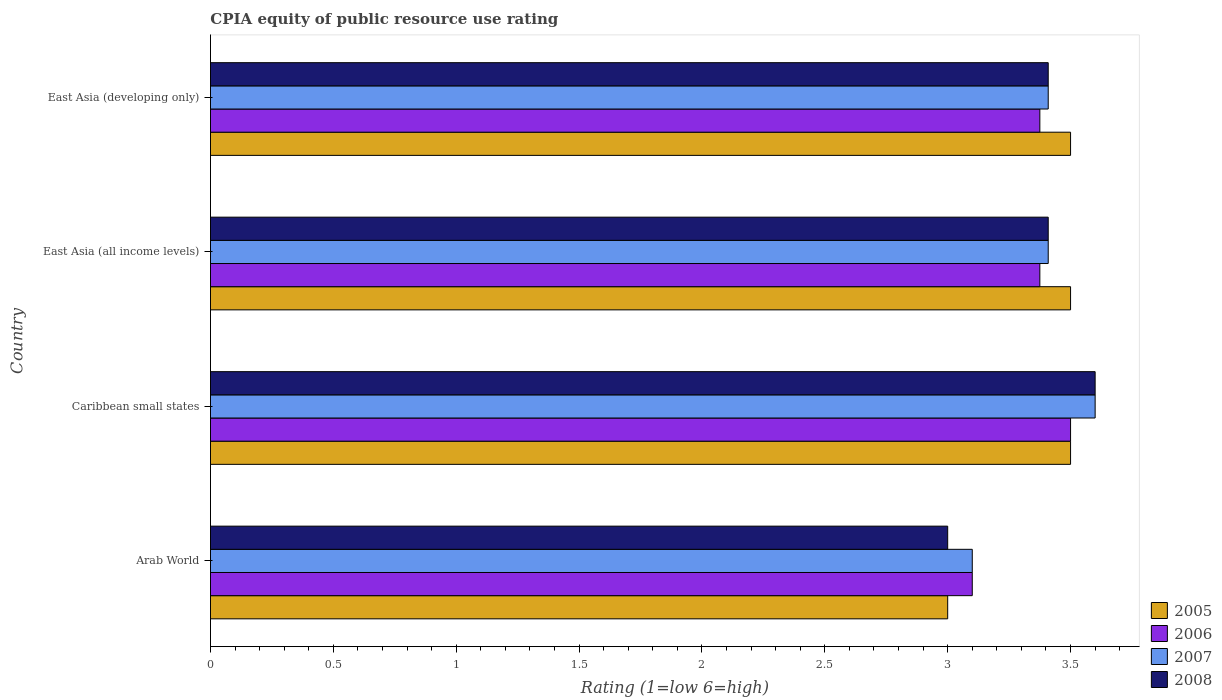Are the number of bars per tick equal to the number of legend labels?
Your answer should be compact. Yes. How many bars are there on the 2nd tick from the top?
Offer a terse response. 4. How many bars are there on the 2nd tick from the bottom?
Offer a terse response. 4. What is the label of the 2nd group of bars from the top?
Your answer should be very brief. East Asia (all income levels). What is the CPIA rating in 2006 in East Asia (all income levels)?
Keep it short and to the point. 3.38. Across all countries, what is the minimum CPIA rating in 2008?
Ensure brevity in your answer.  3. In which country was the CPIA rating in 2007 maximum?
Provide a short and direct response. Caribbean small states. In which country was the CPIA rating in 2006 minimum?
Offer a very short reply. Arab World. What is the total CPIA rating in 2008 in the graph?
Make the answer very short. 13.42. What is the difference between the CPIA rating in 2005 in East Asia (all income levels) and that in East Asia (developing only)?
Your answer should be compact. 0. What is the difference between the CPIA rating in 2007 in Arab World and the CPIA rating in 2008 in East Asia (developing only)?
Keep it short and to the point. -0.31. What is the average CPIA rating in 2006 per country?
Your response must be concise. 3.34. What is the difference between the CPIA rating in 2008 and CPIA rating in 2005 in East Asia (all income levels)?
Your response must be concise. -0.09. Is the CPIA rating in 2005 in Arab World less than that in Caribbean small states?
Give a very brief answer. Yes. Is the difference between the CPIA rating in 2008 in Arab World and East Asia (all income levels) greater than the difference between the CPIA rating in 2005 in Arab World and East Asia (all income levels)?
Your answer should be very brief. Yes. What is the difference between the highest and the second highest CPIA rating in 2008?
Make the answer very short. 0.19. Is the sum of the CPIA rating in 2007 in Arab World and East Asia (all income levels) greater than the maximum CPIA rating in 2005 across all countries?
Your answer should be very brief. Yes. Is it the case that in every country, the sum of the CPIA rating in 2008 and CPIA rating in 2006 is greater than the CPIA rating in 2007?
Your answer should be compact. Yes. How many bars are there?
Provide a short and direct response. 16. Are the values on the major ticks of X-axis written in scientific E-notation?
Your answer should be compact. No. What is the title of the graph?
Provide a succinct answer. CPIA equity of public resource use rating. What is the label or title of the Y-axis?
Your answer should be very brief. Country. What is the Rating (1=low 6=high) in 2005 in Arab World?
Your answer should be very brief. 3. What is the Rating (1=low 6=high) of 2006 in Arab World?
Keep it short and to the point. 3.1. What is the Rating (1=low 6=high) in 2007 in Arab World?
Offer a terse response. 3.1. What is the Rating (1=low 6=high) in 2007 in Caribbean small states?
Your response must be concise. 3.6. What is the Rating (1=low 6=high) in 2008 in Caribbean small states?
Your answer should be compact. 3.6. What is the Rating (1=low 6=high) of 2005 in East Asia (all income levels)?
Keep it short and to the point. 3.5. What is the Rating (1=low 6=high) of 2006 in East Asia (all income levels)?
Your answer should be compact. 3.38. What is the Rating (1=low 6=high) in 2007 in East Asia (all income levels)?
Provide a succinct answer. 3.41. What is the Rating (1=low 6=high) of 2008 in East Asia (all income levels)?
Make the answer very short. 3.41. What is the Rating (1=low 6=high) of 2006 in East Asia (developing only)?
Provide a succinct answer. 3.38. What is the Rating (1=low 6=high) in 2007 in East Asia (developing only)?
Make the answer very short. 3.41. What is the Rating (1=low 6=high) of 2008 in East Asia (developing only)?
Offer a very short reply. 3.41. Across all countries, what is the minimum Rating (1=low 6=high) in 2006?
Give a very brief answer. 3.1. What is the total Rating (1=low 6=high) in 2005 in the graph?
Keep it short and to the point. 13.5. What is the total Rating (1=low 6=high) of 2006 in the graph?
Your answer should be compact. 13.35. What is the total Rating (1=low 6=high) in 2007 in the graph?
Offer a terse response. 13.52. What is the total Rating (1=low 6=high) of 2008 in the graph?
Your answer should be very brief. 13.42. What is the difference between the Rating (1=low 6=high) in 2005 in Arab World and that in Caribbean small states?
Ensure brevity in your answer.  -0.5. What is the difference between the Rating (1=low 6=high) in 2006 in Arab World and that in Caribbean small states?
Your response must be concise. -0.4. What is the difference between the Rating (1=low 6=high) in 2008 in Arab World and that in Caribbean small states?
Make the answer very short. -0.6. What is the difference between the Rating (1=low 6=high) of 2006 in Arab World and that in East Asia (all income levels)?
Offer a terse response. -0.28. What is the difference between the Rating (1=low 6=high) of 2007 in Arab World and that in East Asia (all income levels)?
Offer a terse response. -0.31. What is the difference between the Rating (1=low 6=high) in 2008 in Arab World and that in East Asia (all income levels)?
Provide a short and direct response. -0.41. What is the difference between the Rating (1=low 6=high) of 2006 in Arab World and that in East Asia (developing only)?
Ensure brevity in your answer.  -0.28. What is the difference between the Rating (1=low 6=high) of 2007 in Arab World and that in East Asia (developing only)?
Keep it short and to the point. -0.31. What is the difference between the Rating (1=low 6=high) in 2008 in Arab World and that in East Asia (developing only)?
Offer a very short reply. -0.41. What is the difference between the Rating (1=low 6=high) in 2007 in Caribbean small states and that in East Asia (all income levels)?
Ensure brevity in your answer.  0.19. What is the difference between the Rating (1=low 6=high) in 2008 in Caribbean small states and that in East Asia (all income levels)?
Offer a terse response. 0.19. What is the difference between the Rating (1=low 6=high) in 2005 in Caribbean small states and that in East Asia (developing only)?
Ensure brevity in your answer.  0. What is the difference between the Rating (1=low 6=high) in 2007 in Caribbean small states and that in East Asia (developing only)?
Offer a terse response. 0.19. What is the difference between the Rating (1=low 6=high) in 2008 in Caribbean small states and that in East Asia (developing only)?
Make the answer very short. 0.19. What is the difference between the Rating (1=low 6=high) of 2006 in East Asia (all income levels) and that in East Asia (developing only)?
Make the answer very short. 0. What is the difference between the Rating (1=low 6=high) of 2007 in East Asia (all income levels) and that in East Asia (developing only)?
Offer a very short reply. 0. What is the difference between the Rating (1=low 6=high) of 2008 in East Asia (all income levels) and that in East Asia (developing only)?
Your response must be concise. 0. What is the difference between the Rating (1=low 6=high) of 2005 in Arab World and the Rating (1=low 6=high) of 2006 in Caribbean small states?
Give a very brief answer. -0.5. What is the difference between the Rating (1=low 6=high) of 2005 in Arab World and the Rating (1=low 6=high) of 2007 in Caribbean small states?
Offer a terse response. -0.6. What is the difference between the Rating (1=low 6=high) of 2005 in Arab World and the Rating (1=low 6=high) of 2008 in Caribbean small states?
Provide a short and direct response. -0.6. What is the difference between the Rating (1=low 6=high) of 2006 in Arab World and the Rating (1=low 6=high) of 2007 in Caribbean small states?
Provide a short and direct response. -0.5. What is the difference between the Rating (1=low 6=high) of 2006 in Arab World and the Rating (1=low 6=high) of 2008 in Caribbean small states?
Your response must be concise. -0.5. What is the difference between the Rating (1=low 6=high) of 2007 in Arab World and the Rating (1=low 6=high) of 2008 in Caribbean small states?
Offer a terse response. -0.5. What is the difference between the Rating (1=low 6=high) of 2005 in Arab World and the Rating (1=low 6=high) of 2006 in East Asia (all income levels)?
Offer a very short reply. -0.38. What is the difference between the Rating (1=low 6=high) of 2005 in Arab World and the Rating (1=low 6=high) of 2007 in East Asia (all income levels)?
Make the answer very short. -0.41. What is the difference between the Rating (1=low 6=high) of 2005 in Arab World and the Rating (1=low 6=high) of 2008 in East Asia (all income levels)?
Your response must be concise. -0.41. What is the difference between the Rating (1=low 6=high) of 2006 in Arab World and the Rating (1=low 6=high) of 2007 in East Asia (all income levels)?
Your answer should be very brief. -0.31. What is the difference between the Rating (1=low 6=high) of 2006 in Arab World and the Rating (1=low 6=high) of 2008 in East Asia (all income levels)?
Ensure brevity in your answer.  -0.31. What is the difference between the Rating (1=low 6=high) in 2007 in Arab World and the Rating (1=low 6=high) in 2008 in East Asia (all income levels)?
Keep it short and to the point. -0.31. What is the difference between the Rating (1=low 6=high) of 2005 in Arab World and the Rating (1=low 6=high) of 2006 in East Asia (developing only)?
Give a very brief answer. -0.38. What is the difference between the Rating (1=low 6=high) of 2005 in Arab World and the Rating (1=low 6=high) of 2007 in East Asia (developing only)?
Provide a succinct answer. -0.41. What is the difference between the Rating (1=low 6=high) of 2005 in Arab World and the Rating (1=low 6=high) of 2008 in East Asia (developing only)?
Keep it short and to the point. -0.41. What is the difference between the Rating (1=low 6=high) of 2006 in Arab World and the Rating (1=low 6=high) of 2007 in East Asia (developing only)?
Your answer should be very brief. -0.31. What is the difference between the Rating (1=low 6=high) of 2006 in Arab World and the Rating (1=low 6=high) of 2008 in East Asia (developing only)?
Provide a short and direct response. -0.31. What is the difference between the Rating (1=low 6=high) in 2007 in Arab World and the Rating (1=low 6=high) in 2008 in East Asia (developing only)?
Provide a succinct answer. -0.31. What is the difference between the Rating (1=low 6=high) of 2005 in Caribbean small states and the Rating (1=low 6=high) of 2006 in East Asia (all income levels)?
Provide a succinct answer. 0.12. What is the difference between the Rating (1=low 6=high) of 2005 in Caribbean small states and the Rating (1=low 6=high) of 2007 in East Asia (all income levels)?
Provide a short and direct response. 0.09. What is the difference between the Rating (1=low 6=high) of 2005 in Caribbean small states and the Rating (1=low 6=high) of 2008 in East Asia (all income levels)?
Provide a succinct answer. 0.09. What is the difference between the Rating (1=low 6=high) in 2006 in Caribbean small states and the Rating (1=low 6=high) in 2007 in East Asia (all income levels)?
Make the answer very short. 0.09. What is the difference between the Rating (1=low 6=high) in 2006 in Caribbean small states and the Rating (1=low 6=high) in 2008 in East Asia (all income levels)?
Provide a short and direct response. 0.09. What is the difference between the Rating (1=low 6=high) in 2007 in Caribbean small states and the Rating (1=low 6=high) in 2008 in East Asia (all income levels)?
Provide a succinct answer. 0.19. What is the difference between the Rating (1=low 6=high) in 2005 in Caribbean small states and the Rating (1=low 6=high) in 2007 in East Asia (developing only)?
Offer a very short reply. 0.09. What is the difference between the Rating (1=low 6=high) of 2005 in Caribbean small states and the Rating (1=low 6=high) of 2008 in East Asia (developing only)?
Your answer should be compact. 0.09. What is the difference between the Rating (1=low 6=high) in 2006 in Caribbean small states and the Rating (1=low 6=high) in 2007 in East Asia (developing only)?
Offer a very short reply. 0.09. What is the difference between the Rating (1=low 6=high) of 2006 in Caribbean small states and the Rating (1=low 6=high) of 2008 in East Asia (developing only)?
Give a very brief answer. 0.09. What is the difference between the Rating (1=low 6=high) of 2007 in Caribbean small states and the Rating (1=low 6=high) of 2008 in East Asia (developing only)?
Offer a very short reply. 0.19. What is the difference between the Rating (1=low 6=high) of 2005 in East Asia (all income levels) and the Rating (1=low 6=high) of 2006 in East Asia (developing only)?
Your answer should be very brief. 0.12. What is the difference between the Rating (1=low 6=high) of 2005 in East Asia (all income levels) and the Rating (1=low 6=high) of 2007 in East Asia (developing only)?
Offer a very short reply. 0.09. What is the difference between the Rating (1=low 6=high) in 2005 in East Asia (all income levels) and the Rating (1=low 6=high) in 2008 in East Asia (developing only)?
Offer a terse response. 0.09. What is the difference between the Rating (1=low 6=high) of 2006 in East Asia (all income levels) and the Rating (1=low 6=high) of 2007 in East Asia (developing only)?
Give a very brief answer. -0.03. What is the difference between the Rating (1=low 6=high) in 2006 in East Asia (all income levels) and the Rating (1=low 6=high) in 2008 in East Asia (developing only)?
Offer a terse response. -0.03. What is the average Rating (1=low 6=high) in 2005 per country?
Keep it short and to the point. 3.38. What is the average Rating (1=low 6=high) in 2006 per country?
Provide a short and direct response. 3.34. What is the average Rating (1=low 6=high) in 2007 per country?
Your answer should be very brief. 3.38. What is the average Rating (1=low 6=high) of 2008 per country?
Ensure brevity in your answer.  3.35. What is the difference between the Rating (1=low 6=high) of 2007 and Rating (1=low 6=high) of 2008 in Arab World?
Provide a short and direct response. 0.1. What is the difference between the Rating (1=low 6=high) in 2005 and Rating (1=low 6=high) in 2006 in Caribbean small states?
Your answer should be compact. 0. What is the difference between the Rating (1=low 6=high) of 2006 and Rating (1=low 6=high) of 2007 in Caribbean small states?
Your response must be concise. -0.1. What is the difference between the Rating (1=low 6=high) of 2007 and Rating (1=low 6=high) of 2008 in Caribbean small states?
Keep it short and to the point. 0. What is the difference between the Rating (1=low 6=high) in 2005 and Rating (1=low 6=high) in 2007 in East Asia (all income levels)?
Offer a terse response. 0.09. What is the difference between the Rating (1=low 6=high) of 2005 and Rating (1=low 6=high) of 2008 in East Asia (all income levels)?
Offer a very short reply. 0.09. What is the difference between the Rating (1=low 6=high) in 2006 and Rating (1=low 6=high) in 2007 in East Asia (all income levels)?
Make the answer very short. -0.03. What is the difference between the Rating (1=low 6=high) in 2006 and Rating (1=low 6=high) in 2008 in East Asia (all income levels)?
Ensure brevity in your answer.  -0.03. What is the difference between the Rating (1=low 6=high) in 2005 and Rating (1=low 6=high) in 2007 in East Asia (developing only)?
Your answer should be very brief. 0.09. What is the difference between the Rating (1=low 6=high) of 2005 and Rating (1=low 6=high) of 2008 in East Asia (developing only)?
Offer a very short reply. 0.09. What is the difference between the Rating (1=low 6=high) of 2006 and Rating (1=low 6=high) of 2007 in East Asia (developing only)?
Offer a terse response. -0.03. What is the difference between the Rating (1=low 6=high) in 2006 and Rating (1=low 6=high) in 2008 in East Asia (developing only)?
Your answer should be very brief. -0.03. What is the difference between the Rating (1=low 6=high) of 2007 and Rating (1=low 6=high) of 2008 in East Asia (developing only)?
Your answer should be compact. 0. What is the ratio of the Rating (1=low 6=high) of 2006 in Arab World to that in Caribbean small states?
Give a very brief answer. 0.89. What is the ratio of the Rating (1=low 6=high) in 2007 in Arab World to that in Caribbean small states?
Offer a terse response. 0.86. What is the ratio of the Rating (1=low 6=high) of 2008 in Arab World to that in Caribbean small states?
Your response must be concise. 0.83. What is the ratio of the Rating (1=low 6=high) of 2005 in Arab World to that in East Asia (all income levels)?
Your answer should be compact. 0.86. What is the ratio of the Rating (1=low 6=high) of 2006 in Arab World to that in East Asia (all income levels)?
Your answer should be compact. 0.92. What is the ratio of the Rating (1=low 6=high) in 2007 in Arab World to that in East Asia (all income levels)?
Ensure brevity in your answer.  0.91. What is the ratio of the Rating (1=low 6=high) in 2008 in Arab World to that in East Asia (all income levels)?
Your answer should be very brief. 0.88. What is the ratio of the Rating (1=low 6=high) in 2006 in Arab World to that in East Asia (developing only)?
Make the answer very short. 0.92. What is the ratio of the Rating (1=low 6=high) in 2007 in Arab World to that in East Asia (developing only)?
Keep it short and to the point. 0.91. What is the ratio of the Rating (1=low 6=high) in 2007 in Caribbean small states to that in East Asia (all income levels)?
Ensure brevity in your answer.  1.06. What is the ratio of the Rating (1=low 6=high) of 2008 in Caribbean small states to that in East Asia (all income levels)?
Ensure brevity in your answer.  1.06. What is the ratio of the Rating (1=low 6=high) in 2006 in Caribbean small states to that in East Asia (developing only)?
Offer a terse response. 1.04. What is the ratio of the Rating (1=low 6=high) in 2007 in Caribbean small states to that in East Asia (developing only)?
Make the answer very short. 1.06. What is the ratio of the Rating (1=low 6=high) in 2008 in Caribbean small states to that in East Asia (developing only)?
Your answer should be compact. 1.06. What is the ratio of the Rating (1=low 6=high) in 2005 in East Asia (all income levels) to that in East Asia (developing only)?
Offer a very short reply. 1. What is the ratio of the Rating (1=low 6=high) of 2006 in East Asia (all income levels) to that in East Asia (developing only)?
Provide a succinct answer. 1. What is the ratio of the Rating (1=low 6=high) in 2007 in East Asia (all income levels) to that in East Asia (developing only)?
Make the answer very short. 1. What is the difference between the highest and the second highest Rating (1=low 6=high) in 2006?
Make the answer very short. 0.12. What is the difference between the highest and the second highest Rating (1=low 6=high) of 2007?
Offer a very short reply. 0.19. What is the difference between the highest and the second highest Rating (1=low 6=high) of 2008?
Make the answer very short. 0.19. What is the difference between the highest and the lowest Rating (1=low 6=high) in 2005?
Make the answer very short. 0.5. What is the difference between the highest and the lowest Rating (1=low 6=high) in 2008?
Provide a succinct answer. 0.6. 